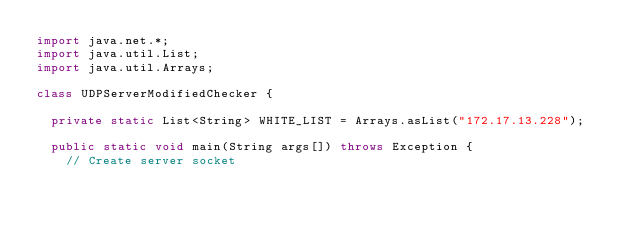<code> <loc_0><loc_0><loc_500><loc_500><_Java_>import java.net.*;
import java.util.List;
import java.util.Arrays;

class UDPServerModifiedChecker {

  private static List<String> WHITE_LIST = Arrays.asList("172.17.13.228");

  public static void main(String args[]) throws Exception {
    // Create server socket</code> 